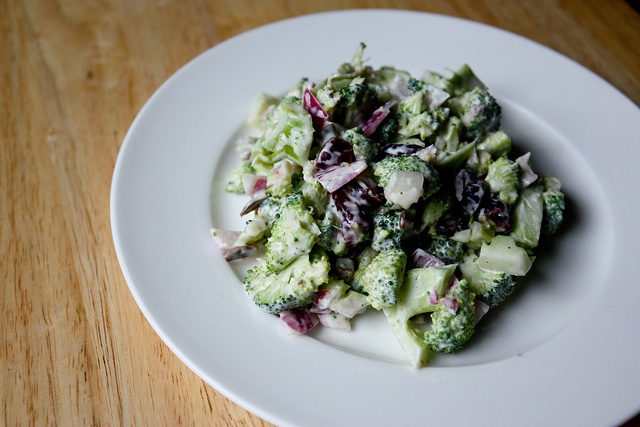Describe the objects in this image and their specific colors. I can see dining table in olive and tan tones, broccoli in olive, beige, and darkgray tones, broccoli in olive, black, gray, darkgray, and darkgreen tones, broccoli in olive, black, darkgray, gray, and lightgray tones, and broccoli in olive, darkgray, black, gray, and darkgreen tones in this image. 